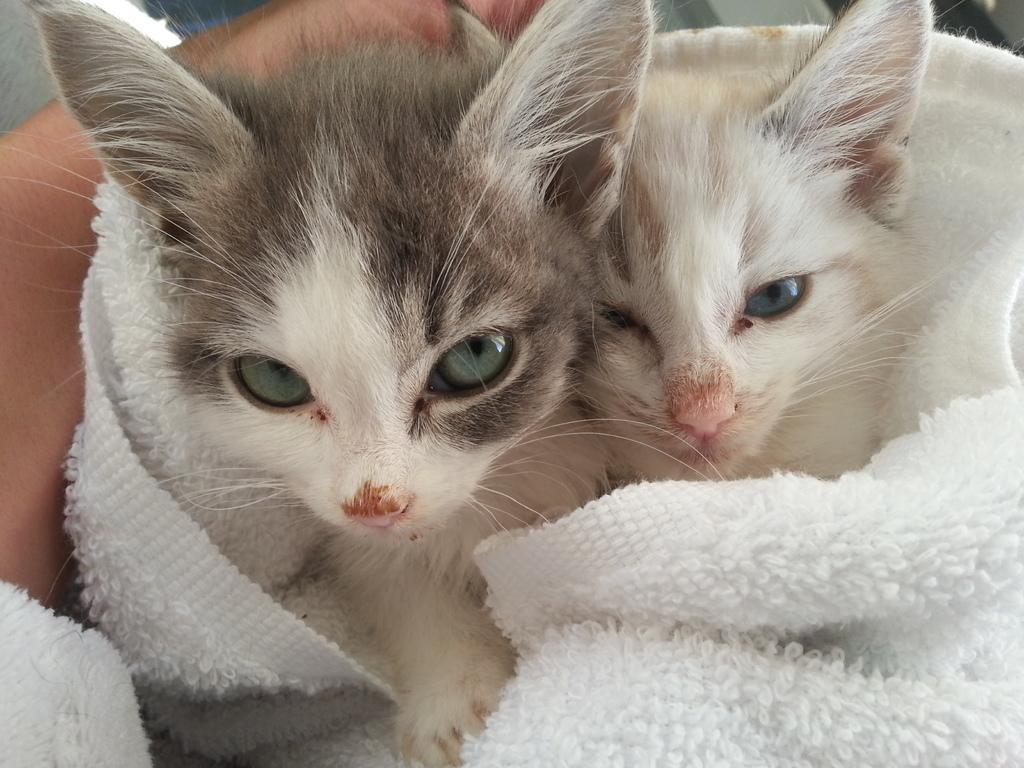Can you describe this image briefly? In the foreground of the image there are two cats wrapped in a cloth. To the left side of the image there is persons hand. 